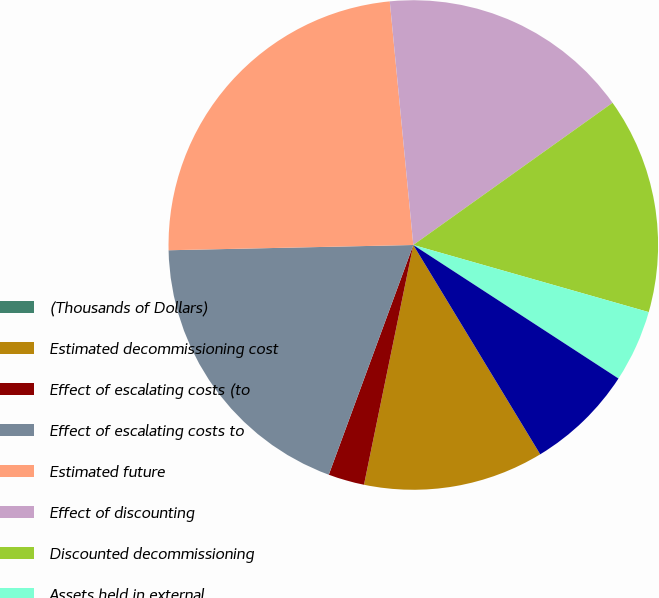Convert chart to OTSL. <chart><loc_0><loc_0><loc_500><loc_500><pie_chart><fcel>(Thousands of Dollars)<fcel>Estimated decommissioning cost<fcel>Effect of escalating costs (to<fcel>Effect of escalating costs to<fcel>Estimated future<fcel>Effect of discounting<fcel>Discounted decommissioning<fcel>Assets held in external<fcel>Underfunding of external<nl><fcel>0.0%<fcel>11.9%<fcel>2.38%<fcel>19.04%<fcel>23.8%<fcel>16.66%<fcel>14.28%<fcel>4.76%<fcel>7.14%<nl></chart> 